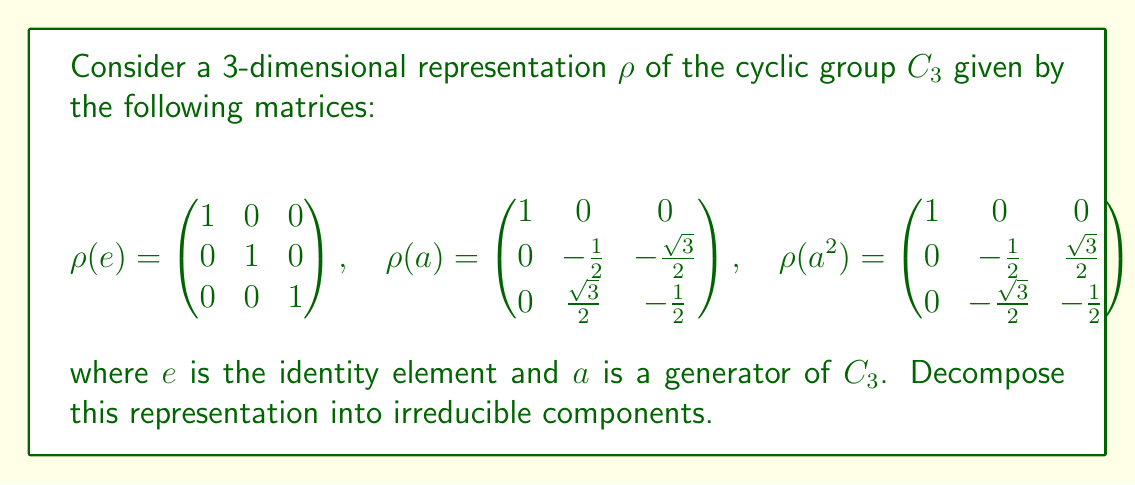What is the answer to this math problem? To decompose this representation into irreducible components, we'll follow these steps:

1) First, recall that for $C_3$, there are three irreducible representations: the trivial representation and two 1-dimensional representations given by the cube roots of unity.

2) Looking at the matrices, we can see that the first row and column are always (1,0,0). This suggests that the representation splits into a 1-dimensional and a 2-dimensional part.

3) The 1-dimensional part is clearly the trivial representation, as it's always 1.

4) For the 2-dimensional part, we need to check if it's irreducible. The matrices for this part are:

   $$\begin{pmatrix}
   -\frac{1}{2} & -\frac{\sqrt{3}}{2} \\
   \frac{\sqrt{3}}{2} & -\frac{1}{2}
   \end{pmatrix} \quad \text{and} \quad
   \begin{pmatrix}
   -\frac{1}{2} & \frac{\sqrt{3}}{2} \\
   -\frac{\sqrt{3}}{2} & -\frac{1}{2}
   \end{pmatrix}$$

5) These matrices represent rotations by $2\pi/3$ and $4\pi/3$ respectively. This is the standard 2-dimensional irreducible representation of $C_3$.

6) Therefore, our representation decomposes as:

   $\rho = \rho_1 \oplus \rho_2$

   where $\rho_1$ is the 1-dimensional trivial representation and $\rho_2$ is the 2-dimensional irreducible representation.
Answer: $\rho = \rho_1 \oplus \rho_2$ (1-dimensional trivial + 2-dimensional irreducible) 